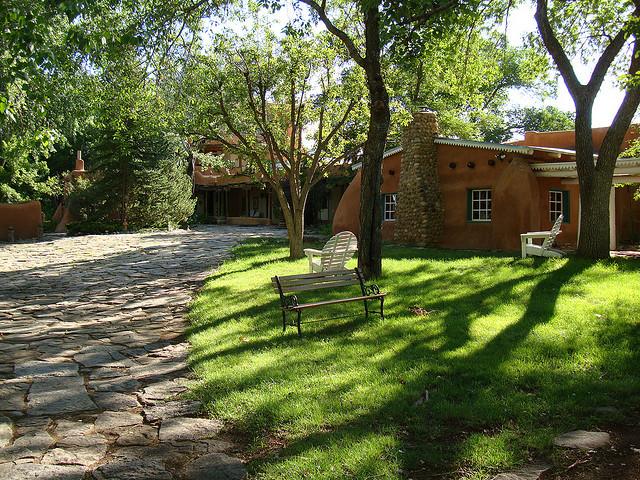How tall is the tallest tree in the yard?
Quick response, please. 20 feet. Does the house have a chimney?
Concise answer only. Yes. What color are the chairs on the lawn?
Answer briefly. White. 